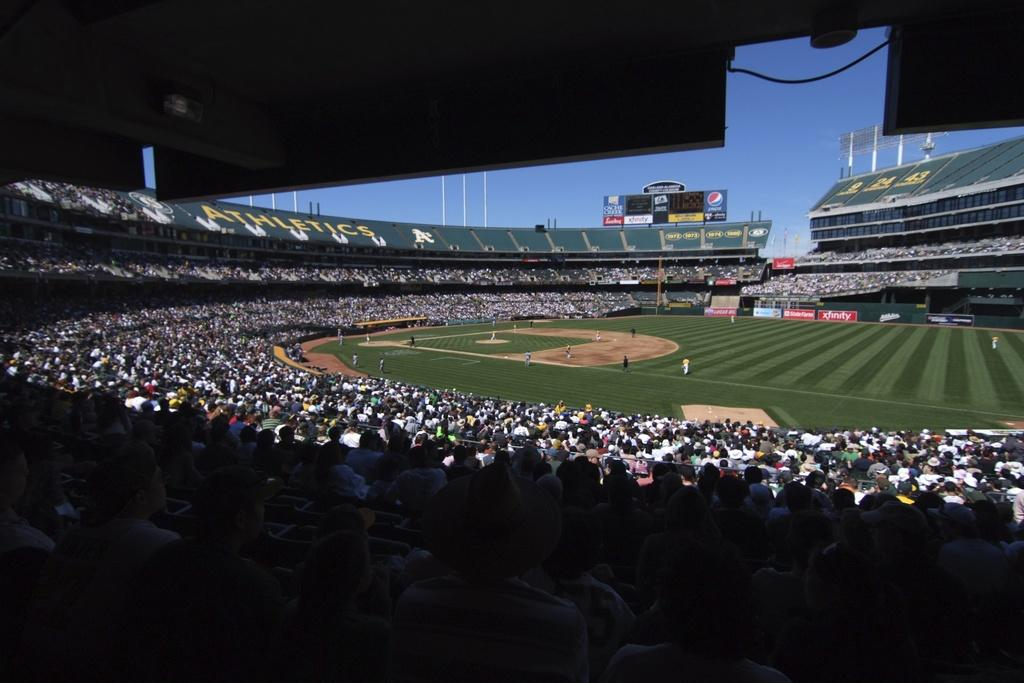What type of location is depicted in the image? The image is of a stadium. Can you describe the people in the image? There is a group of people in the image. What structures are present in the stadium? There are poles, lights, boards, and screens in the image. What can be seen in the background of the image? The sky is visible in the background of the image. What caption is written on the boards in the image? There is no caption visible on the boards in the image. What statement can be made about the middle of the image? The question about the middle of the image is unclear, as there is no specific reference point mentioned. However, the image is of a stadium, and the group of people is likely in the middle of the stands or field. 